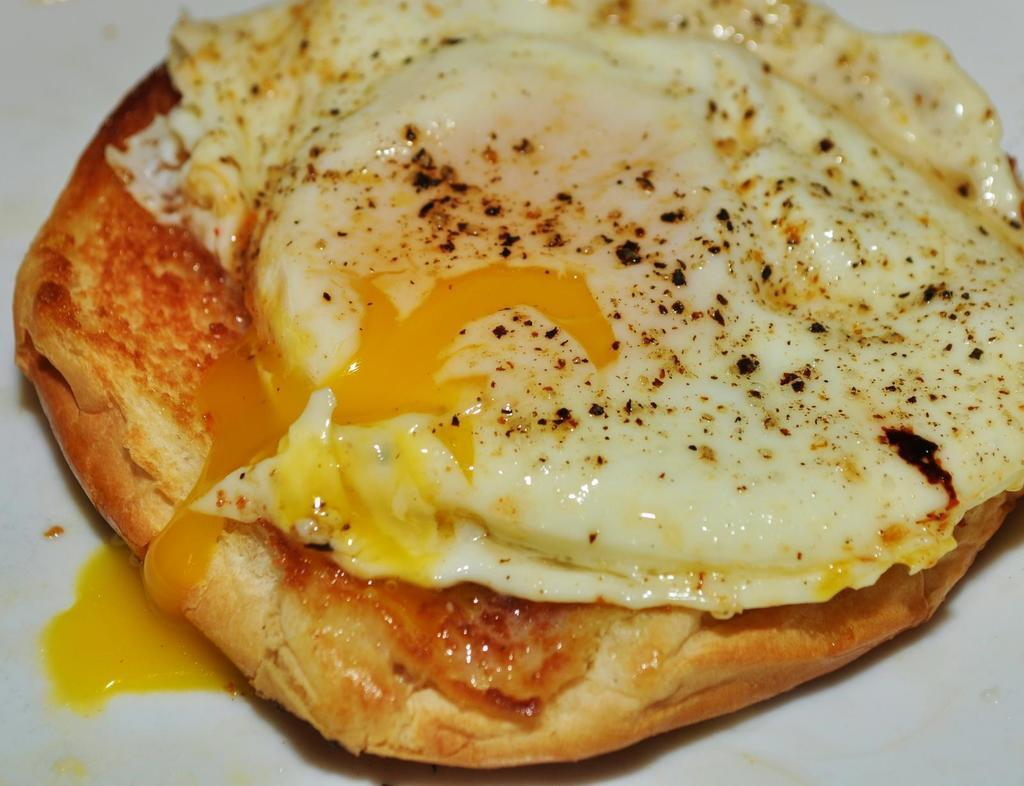What is the main subject of the image? There is a food item in the image. Can you describe the surface on which the food item is placed? The food item is on a white surface. How many horses are visible under the umbrella in the image? There are no horses or umbrellas present in the image; it features a food item on a white surface. 